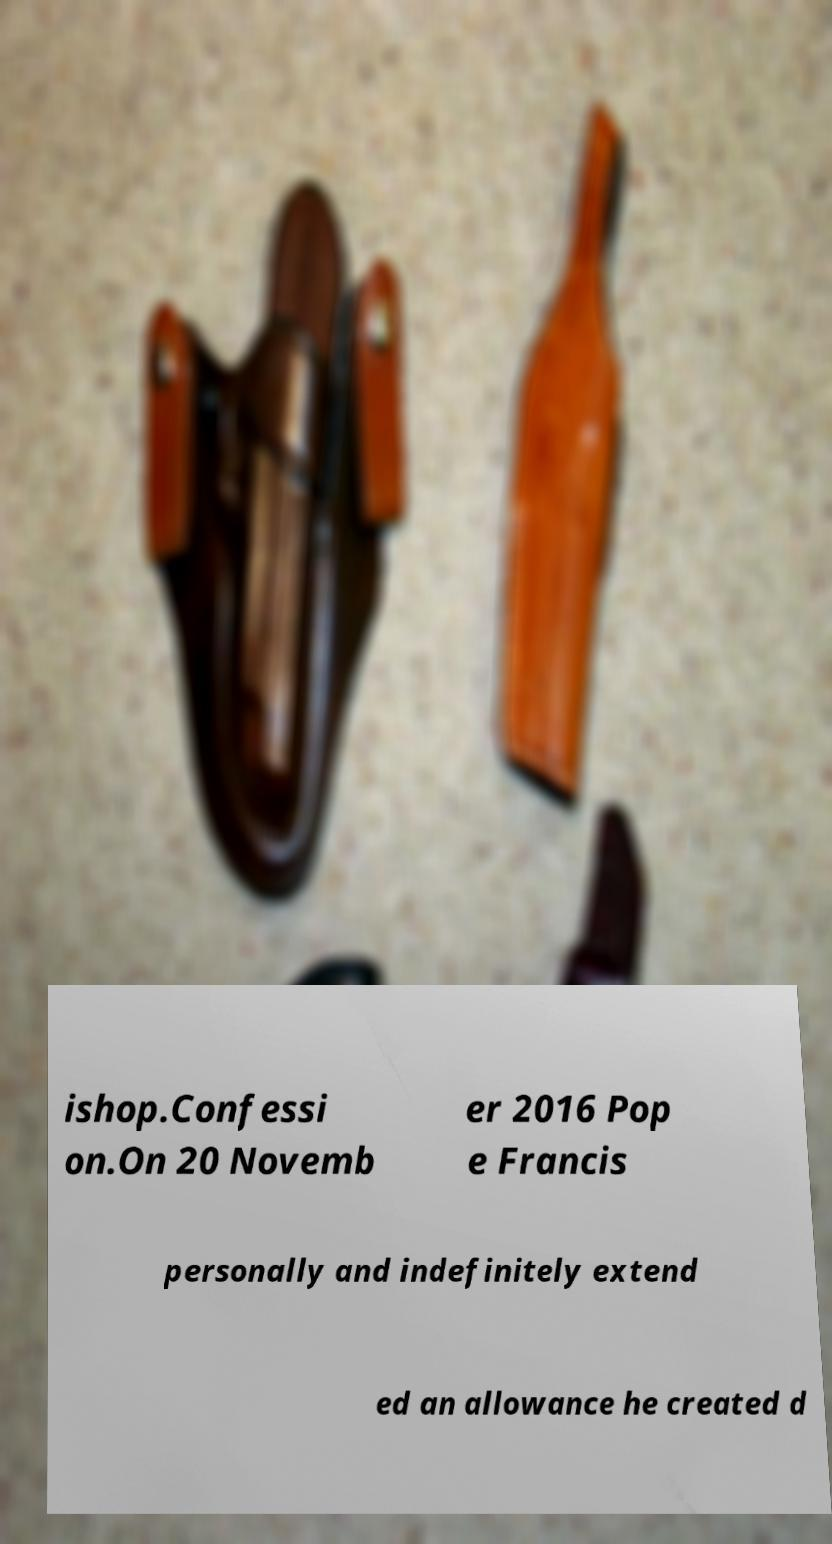Can you read and provide the text displayed in the image?This photo seems to have some interesting text. Can you extract and type it out for me? ishop.Confessi on.On 20 Novemb er 2016 Pop e Francis personally and indefinitely extend ed an allowance he created d 